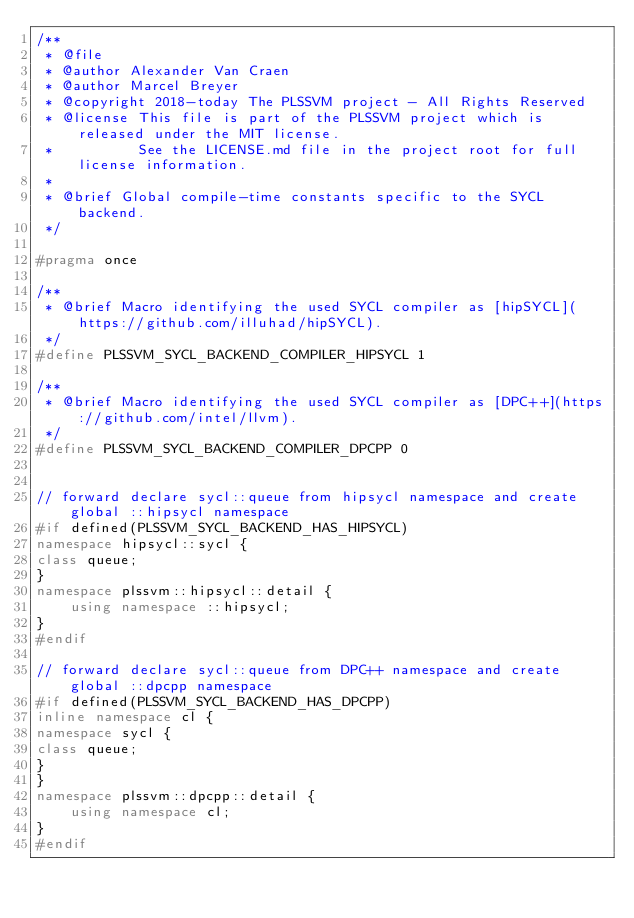<code> <loc_0><loc_0><loc_500><loc_500><_C++_>/**
 * @file
 * @author Alexander Van Craen
 * @author Marcel Breyer
 * @copyright 2018-today The PLSSVM project - All Rights Reserved
 * @license This file is part of the PLSSVM project which is released under the MIT license.
 *          See the LICENSE.md file in the project root for full license information.
 *
 * @brief Global compile-time constants specific to the SYCL backend.
 */

#pragma once

/**
 * @brief Macro identifying the used SYCL compiler as [hipSYCL](https://github.com/illuhad/hipSYCL).
 */
#define PLSSVM_SYCL_BACKEND_COMPILER_HIPSYCL 1

/**
 * @brief Macro identifying the used SYCL compiler as [DPC++](https://github.com/intel/llvm).
 */
#define PLSSVM_SYCL_BACKEND_COMPILER_DPCPP 0


// forward declare sycl::queue from hipsycl namespace and create global ::hipsycl namespace
#if defined(PLSSVM_SYCL_BACKEND_HAS_HIPSYCL)
namespace hipsycl::sycl {
class queue;
}
namespace plssvm::hipsycl::detail {
    using namespace ::hipsycl;
}
#endif

// forward declare sycl::queue from DPC++ namespace and create global ::dpcpp namespace
#if defined(PLSSVM_SYCL_BACKEND_HAS_DPCPP)
inline namespace cl {
namespace sycl {
class queue;
}
}
namespace plssvm::dpcpp::detail {
    using namespace cl;
}
#endif</code> 